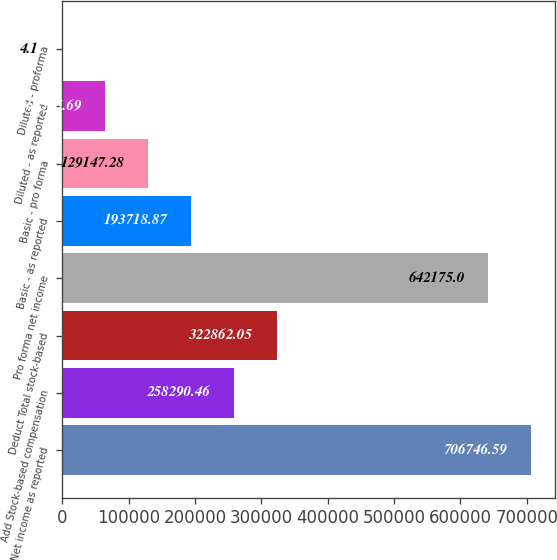Convert chart to OTSL. <chart><loc_0><loc_0><loc_500><loc_500><bar_chart><fcel>Net income as reported<fcel>Add Stock-based compensation<fcel>Deduct Total stock-based<fcel>Pro forma net income<fcel>Basic - as reported<fcel>Basic - pro forma<fcel>Diluted - as reported<fcel>Diluted - proforma<nl><fcel>706747<fcel>258290<fcel>322862<fcel>642175<fcel>193719<fcel>129147<fcel>64575.7<fcel>4.1<nl></chart> 